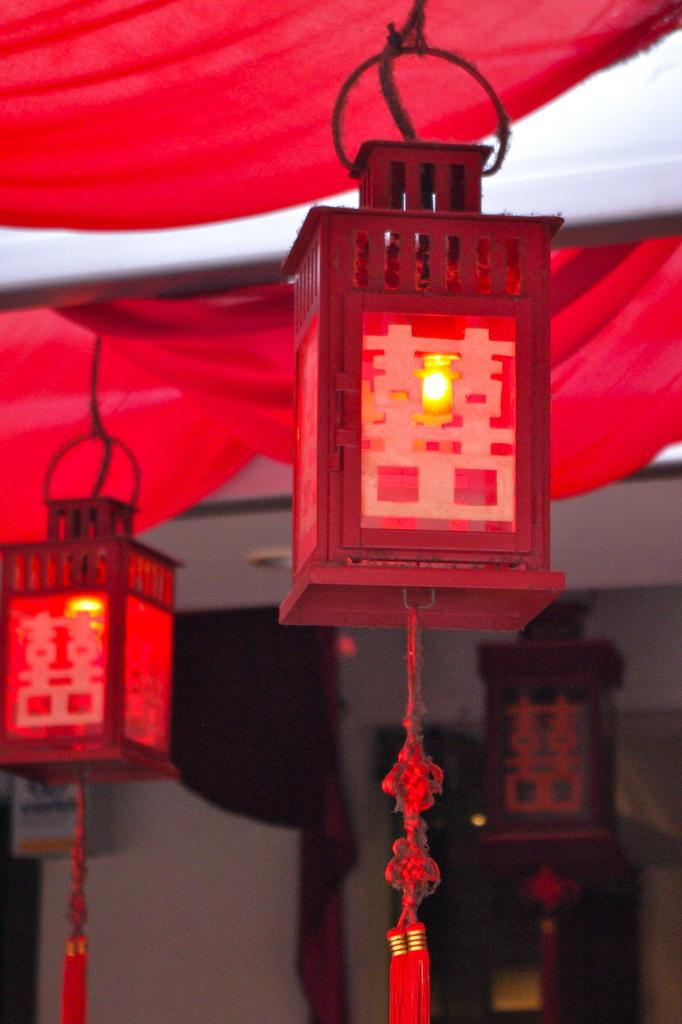What is hanging from the ceiling in the image? There are lights hanging from the ceiling in the image. What is covering the lights? There is cloth above the lights. What can be seen in the background of the image? There is a wall visible in the background of the image. What is the level of excitement in the image? There is no indication of excitement or any activity in the image, as it only shows lights hanging from the ceiling with cloth above them and a wall in the background. What is your opinion on the design of the cloth above the lights? As I am not looking at the image directly, I cannot provide an opinion on the design of the cloth above the lights. 